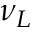Convert formula to latex. <formula><loc_0><loc_0><loc_500><loc_500>\nu _ { L }</formula> 